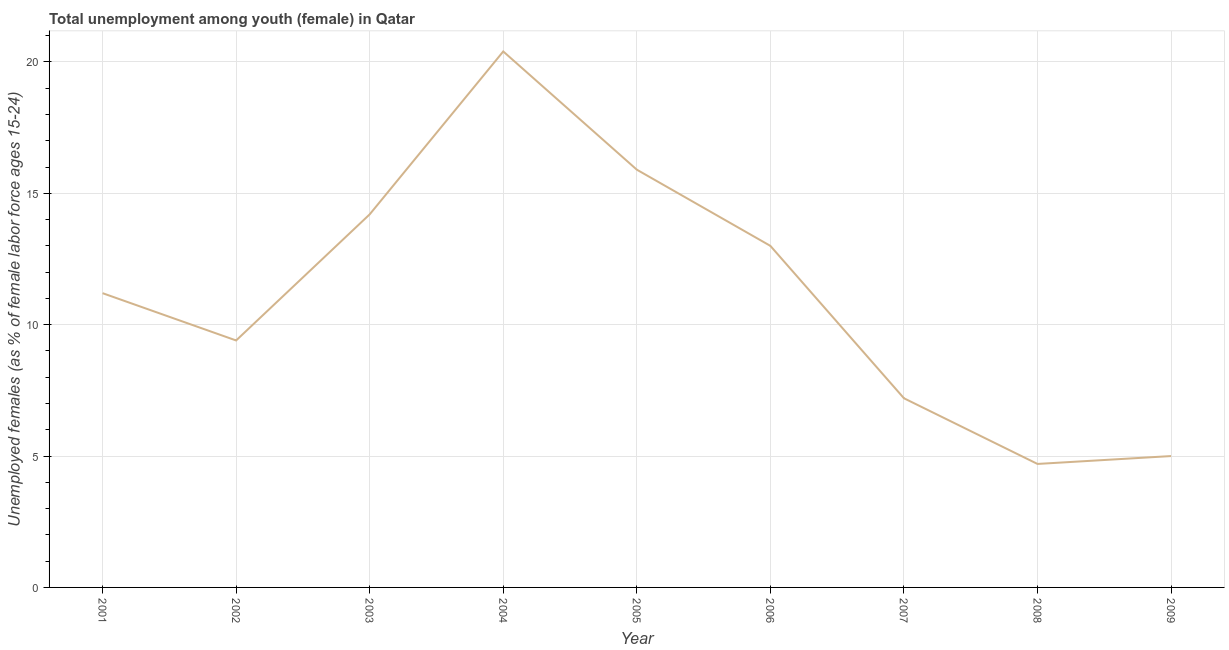What is the unemployed female youth population in 2002?
Ensure brevity in your answer.  9.4. Across all years, what is the maximum unemployed female youth population?
Make the answer very short. 20.4. Across all years, what is the minimum unemployed female youth population?
Offer a very short reply. 4.7. In which year was the unemployed female youth population maximum?
Give a very brief answer. 2004. In which year was the unemployed female youth population minimum?
Ensure brevity in your answer.  2008. What is the sum of the unemployed female youth population?
Your response must be concise. 101. What is the difference between the unemployed female youth population in 2007 and 2008?
Offer a very short reply. 2.5. What is the average unemployed female youth population per year?
Make the answer very short. 11.22. What is the median unemployed female youth population?
Provide a succinct answer. 11.2. In how many years, is the unemployed female youth population greater than 9 %?
Keep it short and to the point. 6. What is the ratio of the unemployed female youth population in 2001 to that in 2004?
Your answer should be compact. 0.55. What is the difference between the highest and the second highest unemployed female youth population?
Keep it short and to the point. 4.5. What is the difference between the highest and the lowest unemployed female youth population?
Offer a very short reply. 15.7. What is the title of the graph?
Your response must be concise. Total unemployment among youth (female) in Qatar. What is the label or title of the X-axis?
Make the answer very short. Year. What is the label or title of the Y-axis?
Provide a succinct answer. Unemployed females (as % of female labor force ages 15-24). What is the Unemployed females (as % of female labor force ages 15-24) of 2001?
Make the answer very short. 11.2. What is the Unemployed females (as % of female labor force ages 15-24) of 2002?
Provide a succinct answer. 9.4. What is the Unemployed females (as % of female labor force ages 15-24) in 2003?
Offer a terse response. 14.2. What is the Unemployed females (as % of female labor force ages 15-24) in 2004?
Provide a succinct answer. 20.4. What is the Unemployed females (as % of female labor force ages 15-24) of 2005?
Offer a very short reply. 15.9. What is the Unemployed females (as % of female labor force ages 15-24) of 2007?
Provide a short and direct response. 7.2. What is the Unemployed females (as % of female labor force ages 15-24) of 2008?
Your answer should be very brief. 4.7. What is the difference between the Unemployed females (as % of female labor force ages 15-24) in 2001 and 2002?
Your answer should be very brief. 1.8. What is the difference between the Unemployed females (as % of female labor force ages 15-24) in 2001 and 2006?
Provide a short and direct response. -1.8. What is the difference between the Unemployed females (as % of female labor force ages 15-24) in 2001 and 2007?
Give a very brief answer. 4. What is the difference between the Unemployed females (as % of female labor force ages 15-24) in 2001 and 2008?
Your answer should be compact. 6.5. What is the difference between the Unemployed females (as % of female labor force ages 15-24) in 2002 and 2004?
Your answer should be very brief. -11. What is the difference between the Unemployed females (as % of female labor force ages 15-24) in 2002 and 2005?
Keep it short and to the point. -6.5. What is the difference between the Unemployed females (as % of female labor force ages 15-24) in 2002 and 2006?
Give a very brief answer. -3.6. What is the difference between the Unemployed females (as % of female labor force ages 15-24) in 2002 and 2007?
Your answer should be compact. 2.2. What is the difference between the Unemployed females (as % of female labor force ages 15-24) in 2002 and 2009?
Offer a terse response. 4.4. What is the difference between the Unemployed females (as % of female labor force ages 15-24) in 2003 and 2004?
Make the answer very short. -6.2. What is the difference between the Unemployed females (as % of female labor force ages 15-24) in 2003 and 2007?
Keep it short and to the point. 7. What is the difference between the Unemployed females (as % of female labor force ages 15-24) in 2005 and 2008?
Keep it short and to the point. 11.2. What is the difference between the Unemployed females (as % of female labor force ages 15-24) in 2006 and 2007?
Provide a succinct answer. 5.8. What is the difference between the Unemployed females (as % of female labor force ages 15-24) in 2006 and 2009?
Ensure brevity in your answer.  8. What is the difference between the Unemployed females (as % of female labor force ages 15-24) in 2007 and 2008?
Your answer should be very brief. 2.5. What is the ratio of the Unemployed females (as % of female labor force ages 15-24) in 2001 to that in 2002?
Offer a very short reply. 1.19. What is the ratio of the Unemployed females (as % of female labor force ages 15-24) in 2001 to that in 2003?
Your answer should be compact. 0.79. What is the ratio of the Unemployed females (as % of female labor force ages 15-24) in 2001 to that in 2004?
Give a very brief answer. 0.55. What is the ratio of the Unemployed females (as % of female labor force ages 15-24) in 2001 to that in 2005?
Keep it short and to the point. 0.7. What is the ratio of the Unemployed females (as % of female labor force ages 15-24) in 2001 to that in 2006?
Provide a succinct answer. 0.86. What is the ratio of the Unemployed females (as % of female labor force ages 15-24) in 2001 to that in 2007?
Provide a short and direct response. 1.56. What is the ratio of the Unemployed females (as % of female labor force ages 15-24) in 2001 to that in 2008?
Your answer should be very brief. 2.38. What is the ratio of the Unemployed females (as % of female labor force ages 15-24) in 2001 to that in 2009?
Keep it short and to the point. 2.24. What is the ratio of the Unemployed females (as % of female labor force ages 15-24) in 2002 to that in 2003?
Your response must be concise. 0.66. What is the ratio of the Unemployed females (as % of female labor force ages 15-24) in 2002 to that in 2004?
Your response must be concise. 0.46. What is the ratio of the Unemployed females (as % of female labor force ages 15-24) in 2002 to that in 2005?
Make the answer very short. 0.59. What is the ratio of the Unemployed females (as % of female labor force ages 15-24) in 2002 to that in 2006?
Offer a very short reply. 0.72. What is the ratio of the Unemployed females (as % of female labor force ages 15-24) in 2002 to that in 2007?
Offer a very short reply. 1.31. What is the ratio of the Unemployed females (as % of female labor force ages 15-24) in 2002 to that in 2009?
Ensure brevity in your answer.  1.88. What is the ratio of the Unemployed females (as % of female labor force ages 15-24) in 2003 to that in 2004?
Provide a succinct answer. 0.7. What is the ratio of the Unemployed females (as % of female labor force ages 15-24) in 2003 to that in 2005?
Ensure brevity in your answer.  0.89. What is the ratio of the Unemployed females (as % of female labor force ages 15-24) in 2003 to that in 2006?
Your answer should be compact. 1.09. What is the ratio of the Unemployed females (as % of female labor force ages 15-24) in 2003 to that in 2007?
Offer a terse response. 1.97. What is the ratio of the Unemployed females (as % of female labor force ages 15-24) in 2003 to that in 2008?
Your answer should be very brief. 3.02. What is the ratio of the Unemployed females (as % of female labor force ages 15-24) in 2003 to that in 2009?
Provide a short and direct response. 2.84. What is the ratio of the Unemployed females (as % of female labor force ages 15-24) in 2004 to that in 2005?
Offer a terse response. 1.28. What is the ratio of the Unemployed females (as % of female labor force ages 15-24) in 2004 to that in 2006?
Offer a terse response. 1.57. What is the ratio of the Unemployed females (as % of female labor force ages 15-24) in 2004 to that in 2007?
Offer a terse response. 2.83. What is the ratio of the Unemployed females (as % of female labor force ages 15-24) in 2004 to that in 2008?
Your response must be concise. 4.34. What is the ratio of the Unemployed females (as % of female labor force ages 15-24) in 2004 to that in 2009?
Ensure brevity in your answer.  4.08. What is the ratio of the Unemployed females (as % of female labor force ages 15-24) in 2005 to that in 2006?
Give a very brief answer. 1.22. What is the ratio of the Unemployed females (as % of female labor force ages 15-24) in 2005 to that in 2007?
Your response must be concise. 2.21. What is the ratio of the Unemployed females (as % of female labor force ages 15-24) in 2005 to that in 2008?
Your answer should be very brief. 3.38. What is the ratio of the Unemployed females (as % of female labor force ages 15-24) in 2005 to that in 2009?
Your answer should be very brief. 3.18. What is the ratio of the Unemployed females (as % of female labor force ages 15-24) in 2006 to that in 2007?
Provide a succinct answer. 1.81. What is the ratio of the Unemployed females (as % of female labor force ages 15-24) in 2006 to that in 2008?
Make the answer very short. 2.77. What is the ratio of the Unemployed females (as % of female labor force ages 15-24) in 2007 to that in 2008?
Ensure brevity in your answer.  1.53. What is the ratio of the Unemployed females (as % of female labor force ages 15-24) in 2007 to that in 2009?
Offer a terse response. 1.44. What is the ratio of the Unemployed females (as % of female labor force ages 15-24) in 2008 to that in 2009?
Your answer should be compact. 0.94. 